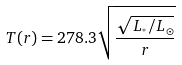Convert formula to latex. <formula><loc_0><loc_0><loc_500><loc_500>T ( r ) = 2 7 8 . 3 \sqrt { \frac { \sqrt { L _ { ^ { * } } / L _ { \odot } } } { r } }</formula> 